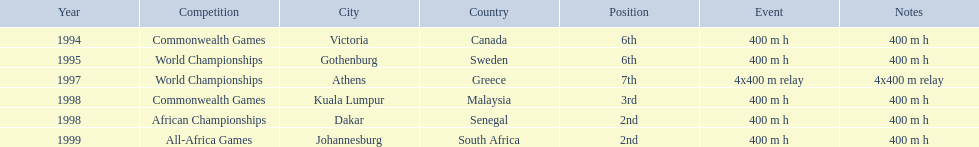What venue came before gothenburg, sweden? Victoria, Canada. 